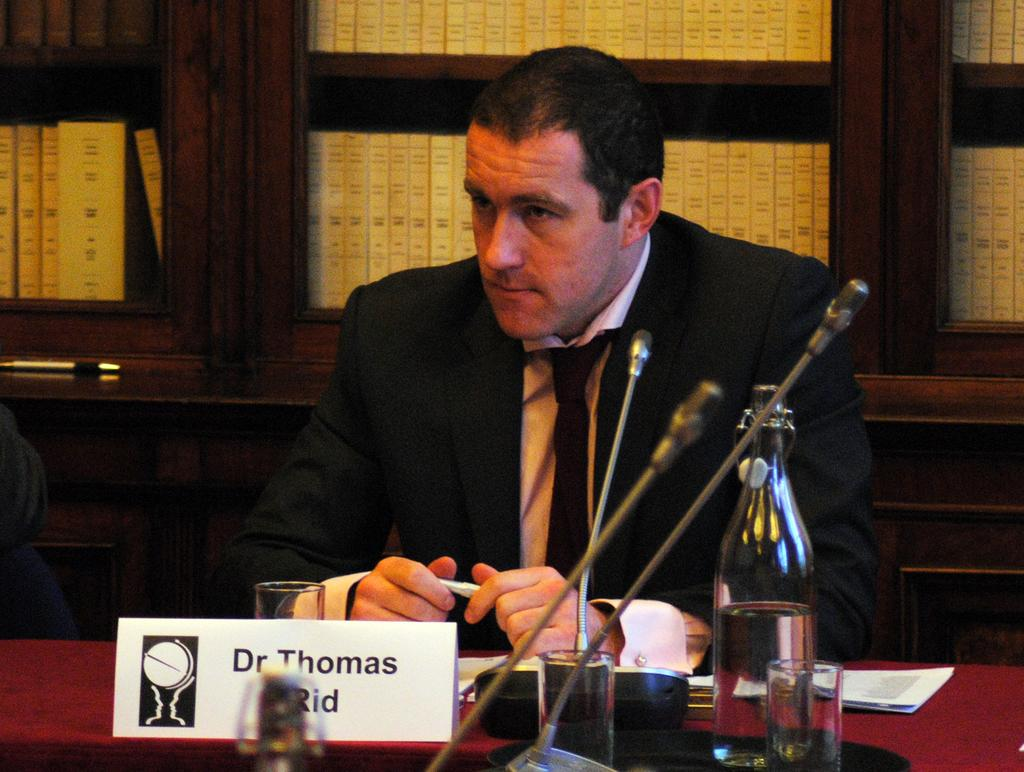What is the man in the image doing? The man is sitting next to a table in the image. What objects are on the table in the image? There is a bottle, glasses, and microphones on the table in the image. What can be seen in the background of the image? There are files visible in the background of the image. What type of plants can be seen growing on the table in the image? There are no plants visible on the table in the image. What is the cause of the man's presence in the image? The image does not provide information about the cause of the man's presence, so we cannot determine the reason for his presence. 